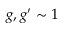<formula> <loc_0><loc_0><loc_500><loc_500>g , g ^ { \prime } \sim 1</formula> 